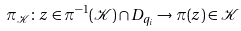<formula> <loc_0><loc_0><loc_500><loc_500>\pi _ { \mathcal { K } } \colon z \in \pi ^ { - 1 } ( \mathcal { K } ) \cap D _ { q _ { i } } \to \pi ( z ) \in \mathcal { K }</formula> 